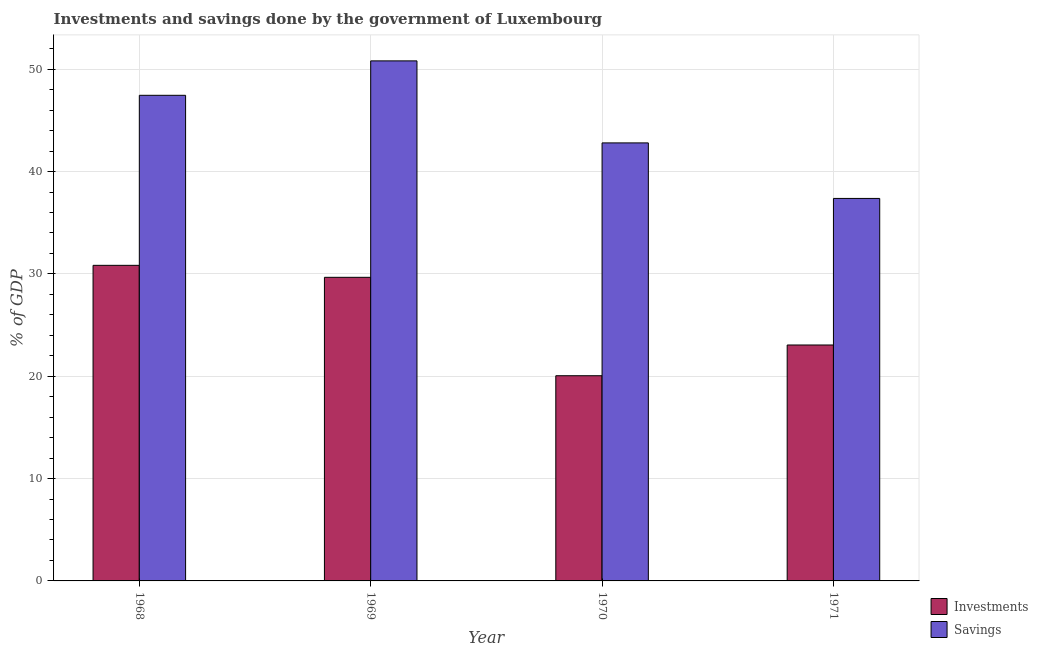How many different coloured bars are there?
Give a very brief answer. 2. Are the number of bars on each tick of the X-axis equal?
Ensure brevity in your answer.  Yes. How many bars are there on the 4th tick from the left?
Make the answer very short. 2. How many bars are there on the 4th tick from the right?
Ensure brevity in your answer.  2. What is the label of the 3rd group of bars from the left?
Make the answer very short. 1970. What is the savings of government in 1969?
Your answer should be very brief. 50.82. Across all years, what is the maximum investments of government?
Ensure brevity in your answer.  30.84. Across all years, what is the minimum savings of government?
Provide a succinct answer. 37.38. In which year was the savings of government maximum?
Your answer should be very brief. 1969. What is the total savings of government in the graph?
Provide a succinct answer. 178.45. What is the difference between the investments of government in 1968 and that in 1969?
Your answer should be compact. 1.17. What is the difference between the savings of government in 1971 and the investments of government in 1969?
Provide a succinct answer. -13.44. What is the average investments of government per year?
Ensure brevity in your answer.  25.9. What is the ratio of the investments of government in 1969 to that in 1970?
Your answer should be very brief. 1.48. Is the difference between the savings of government in 1969 and 1971 greater than the difference between the investments of government in 1969 and 1971?
Your answer should be very brief. No. What is the difference between the highest and the second highest investments of government?
Make the answer very short. 1.17. What is the difference between the highest and the lowest investments of government?
Your answer should be compact. 10.79. Is the sum of the savings of government in 1968 and 1971 greater than the maximum investments of government across all years?
Offer a very short reply. Yes. What does the 2nd bar from the left in 1970 represents?
Offer a terse response. Savings. What does the 1st bar from the right in 1969 represents?
Your response must be concise. Savings. How many years are there in the graph?
Offer a terse response. 4. Are the values on the major ticks of Y-axis written in scientific E-notation?
Make the answer very short. No. Does the graph contain grids?
Provide a succinct answer. Yes. Where does the legend appear in the graph?
Provide a succinct answer. Bottom right. How are the legend labels stacked?
Give a very brief answer. Vertical. What is the title of the graph?
Provide a succinct answer. Investments and savings done by the government of Luxembourg. What is the label or title of the Y-axis?
Offer a terse response. % of GDP. What is the % of GDP in Investments in 1968?
Offer a terse response. 30.84. What is the % of GDP of Savings in 1968?
Make the answer very short. 47.45. What is the % of GDP in Investments in 1969?
Your answer should be very brief. 29.67. What is the % of GDP in Savings in 1969?
Give a very brief answer. 50.82. What is the % of GDP of Investments in 1970?
Offer a terse response. 20.05. What is the % of GDP in Savings in 1970?
Provide a short and direct response. 42.8. What is the % of GDP of Investments in 1971?
Give a very brief answer. 23.05. What is the % of GDP in Savings in 1971?
Your answer should be compact. 37.38. Across all years, what is the maximum % of GDP in Investments?
Offer a very short reply. 30.84. Across all years, what is the maximum % of GDP of Savings?
Offer a terse response. 50.82. Across all years, what is the minimum % of GDP of Investments?
Make the answer very short. 20.05. Across all years, what is the minimum % of GDP in Savings?
Keep it short and to the point. 37.38. What is the total % of GDP in Investments in the graph?
Keep it short and to the point. 103.61. What is the total % of GDP of Savings in the graph?
Provide a short and direct response. 178.45. What is the difference between the % of GDP in Investments in 1968 and that in 1969?
Offer a terse response. 1.17. What is the difference between the % of GDP of Savings in 1968 and that in 1969?
Ensure brevity in your answer.  -3.36. What is the difference between the % of GDP in Investments in 1968 and that in 1970?
Your answer should be compact. 10.79. What is the difference between the % of GDP of Savings in 1968 and that in 1970?
Offer a terse response. 4.65. What is the difference between the % of GDP in Investments in 1968 and that in 1971?
Your response must be concise. 7.78. What is the difference between the % of GDP of Savings in 1968 and that in 1971?
Your response must be concise. 10.08. What is the difference between the % of GDP in Investments in 1969 and that in 1970?
Give a very brief answer. 9.62. What is the difference between the % of GDP in Savings in 1969 and that in 1970?
Your response must be concise. 8.02. What is the difference between the % of GDP in Investments in 1969 and that in 1971?
Offer a very short reply. 6.61. What is the difference between the % of GDP in Savings in 1969 and that in 1971?
Give a very brief answer. 13.44. What is the difference between the % of GDP of Investments in 1970 and that in 1971?
Your answer should be very brief. -3. What is the difference between the % of GDP of Savings in 1970 and that in 1971?
Your answer should be very brief. 5.43. What is the difference between the % of GDP of Investments in 1968 and the % of GDP of Savings in 1969?
Make the answer very short. -19.98. What is the difference between the % of GDP in Investments in 1968 and the % of GDP in Savings in 1970?
Offer a very short reply. -11.96. What is the difference between the % of GDP in Investments in 1968 and the % of GDP in Savings in 1971?
Your answer should be compact. -6.54. What is the difference between the % of GDP in Investments in 1969 and the % of GDP in Savings in 1970?
Your answer should be very brief. -13.14. What is the difference between the % of GDP of Investments in 1969 and the % of GDP of Savings in 1971?
Provide a short and direct response. -7.71. What is the difference between the % of GDP of Investments in 1970 and the % of GDP of Savings in 1971?
Give a very brief answer. -17.33. What is the average % of GDP of Investments per year?
Your answer should be compact. 25.9. What is the average % of GDP of Savings per year?
Provide a short and direct response. 44.61. In the year 1968, what is the difference between the % of GDP of Investments and % of GDP of Savings?
Offer a very short reply. -16.62. In the year 1969, what is the difference between the % of GDP in Investments and % of GDP in Savings?
Provide a short and direct response. -21.15. In the year 1970, what is the difference between the % of GDP in Investments and % of GDP in Savings?
Provide a succinct answer. -22.75. In the year 1971, what is the difference between the % of GDP of Investments and % of GDP of Savings?
Provide a short and direct response. -14.32. What is the ratio of the % of GDP in Investments in 1968 to that in 1969?
Provide a succinct answer. 1.04. What is the ratio of the % of GDP of Savings in 1968 to that in 1969?
Make the answer very short. 0.93. What is the ratio of the % of GDP in Investments in 1968 to that in 1970?
Make the answer very short. 1.54. What is the ratio of the % of GDP in Savings in 1968 to that in 1970?
Give a very brief answer. 1.11. What is the ratio of the % of GDP of Investments in 1968 to that in 1971?
Your response must be concise. 1.34. What is the ratio of the % of GDP of Savings in 1968 to that in 1971?
Ensure brevity in your answer.  1.27. What is the ratio of the % of GDP in Investments in 1969 to that in 1970?
Your answer should be compact. 1.48. What is the ratio of the % of GDP of Savings in 1969 to that in 1970?
Provide a succinct answer. 1.19. What is the ratio of the % of GDP of Investments in 1969 to that in 1971?
Your answer should be compact. 1.29. What is the ratio of the % of GDP of Savings in 1969 to that in 1971?
Give a very brief answer. 1.36. What is the ratio of the % of GDP of Investments in 1970 to that in 1971?
Make the answer very short. 0.87. What is the ratio of the % of GDP in Savings in 1970 to that in 1971?
Make the answer very short. 1.15. What is the difference between the highest and the second highest % of GDP in Investments?
Give a very brief answer. 1.17. What is the difference between the highest and the second highest % of GDP in Savings?
Your answer should be very brief. 3.36. What is the difference between the highest and the lowest % of GDP in Investments?
Give a very brief answer. 10.79. What is the difference between the highest and the lowest % of GDP in Savings?
Give a very brief answer. 13.44. 